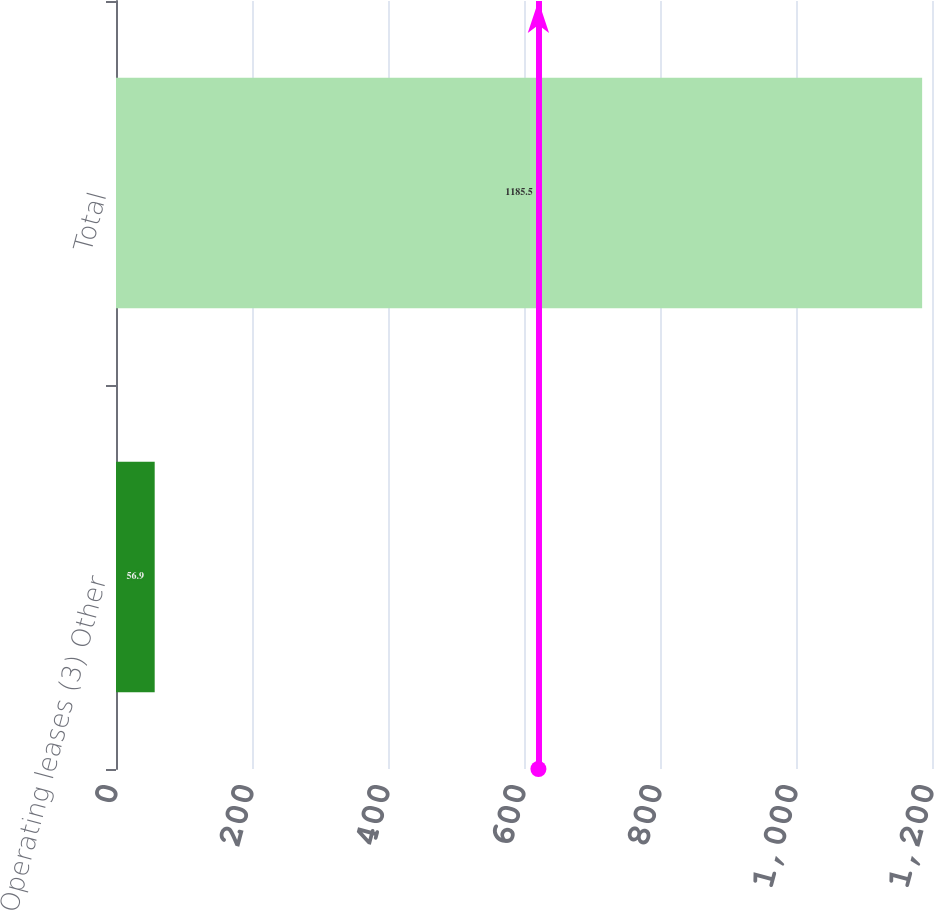Convert chart to OTSL. <chart><loc_0><loc_0><loc_500><loc_500><bar_chart><fcel>Operating leases (3) Other<fcel>Total<nl><fcel>56.9<fcel>1185.5<nl></chart> 